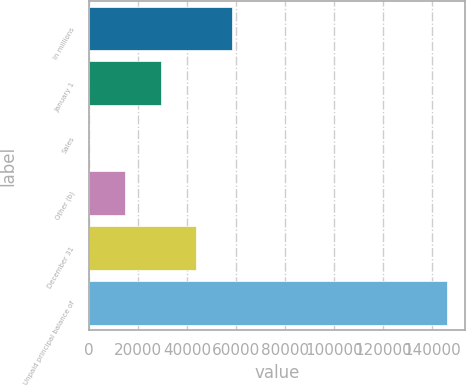Convert chart. <chart><loc_0><loc_0><loc_500><loc_500><bar_chart><fcel>In millions<fcel>January 1<fcel>Sales<fcel>Other (b)<fcel>December 31<fcel>Unpaid principal balance of<nl><fcel>58464.4<fcel>29269.2<fcel>74<fcel>14671.6<fcel>43866.8<fcel>146050<nl></chart> 